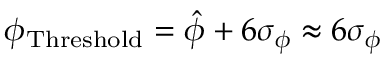<formula> <loc_0><loc_0><loc_500><loc_500>\phi _ { T h r e s h o l d } = \hat { \phi } + 6 \sigma _ { \phi } \approx 6 \sigma _ { \phi }</formula> 